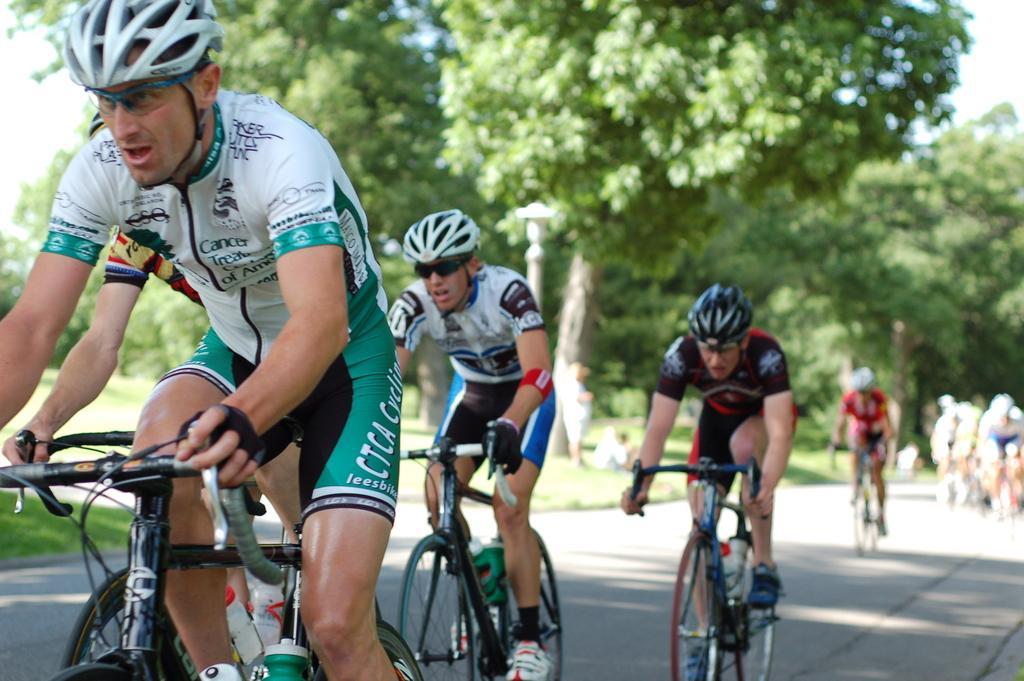Please provide a concise description of this image. In this image we can see few people are riding bicycles on the road. In the background we can see grass, pole, people, trees, and sky. 